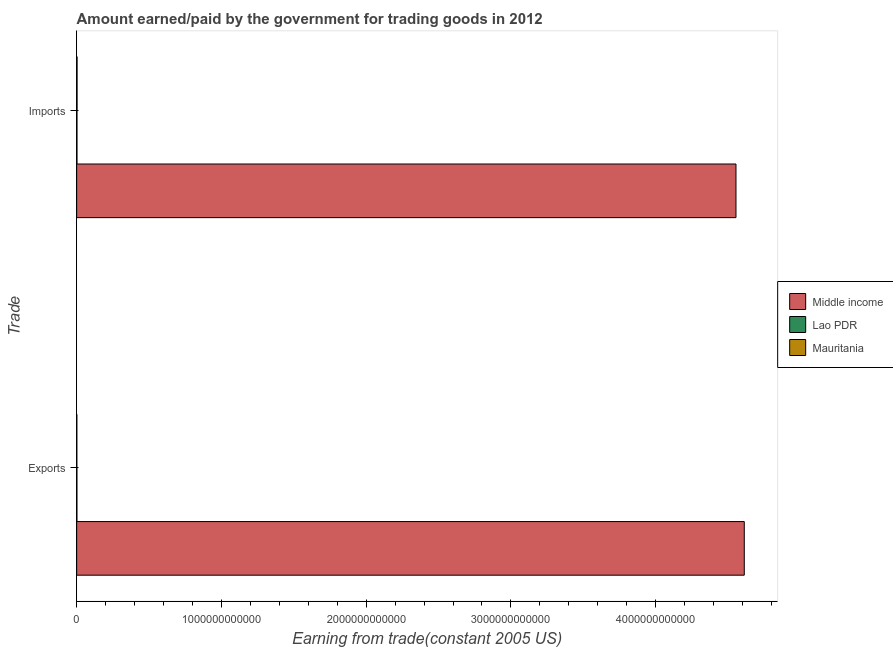How many groups of bars are there?
Provide a short and direct response. 2. Are the number of bars per tick equal to the number of legend labels?
Give a very brief answer. Yes. Are the number of bars on each tick of the Y-axis equal?
Your answer should be very brief. Yes. How many bars are there on the 1st tick from the bottom?
Make the answer very short. 3. What is the label of the 1st group of bars from the top?
Your answer should be very brief. Imports. What is the amount earned from exports in Middle income?
Provide a short and direct response. 4.61e+12. Across all countries, what is the maximum amount earned from exports?
Provide a short and direct response. 4.61e+12. Across all countries, what is the minimum amount paid for imports?
Offer a terse response. 2.28e+09. In which country was the amount paid for imports maximum?
Ensure brevity in your answer.  Middle income. In which country was the amount earned from exports minimum?
Make the answer very short. Mauritania. What is the total amount paid for imports in the graph?
Offer a very short reply. 4.56e+12. What is the difference between the amount earned from exports in Mauritania and that in Lao PDR?
Your answer should be compact. -5.59e+08. What is the difference between the amount paid for imports in Lao PDR and the amount earned from exports in Mauritania?
Your answer should be very brief. 1.02e+09. What is the average amount earned from exports per country?
Offer a terse response. 1.54e+12. What is the difference between the amount paid for imports and amount earned from exports in Lao PDR?
Make the answer very short. 4.61e+08. In how many countries, is the amount earned from exports greater than 2800000000000 US$?
Your answer should be very brief. 1. What is the ratio of the amount paid for imports in Mauritania to that in Middle income?
Provide a succinct answer. 0. In how many countries, is the amount paid for imports greater than the average amount paid for imports taken over all countries?
Your answer should be very brief. 1. What does the 1st bar from the bottom in Exports represents?
Your answer should be compact. Middle income. How many bars are there?
Your answer should be very brief. 6. Are all the bars in the graph horizontal?
Your answer should be very brief. Yes. How many countries are there in the graph?
Make the answer very short. 3. What is the difference between two consecutive major ticks on the X-axis?
Your answer should be very brief. 1.00e+12. Are the values on the major ticks of X-axis written in scientific E-notation?
Offer a very short reply. No. Where does the legend appear in the graph?
Give a very brief answer. Center right. How many legend labels are there?
Offer a terse response. 3. How are the legend labels stacked?
Offer a terse response. Vertical. What is the title of the graph?
Ensure brevity in your answer.  Amount earned/paid by the government for trading goods in 2012. What is the label or title of the X-axis?
Make the answer very short. Earning from trade(constant 2005 US). What is the label or title of the Y-axis?
Your answer should be compact. Trade. What is the Earning from trade(constant 2005 US) of Middle income in Exports?
Make the answer very short. 4.61e+12. What is the Earning from trade(constant 2005 US) of Lao PDR in Exports?
Keep it short and to the point. 1.82e+09. What is the Earning from trade(constant 2005 US) of Mauritania in Exports?
Make the answer very short. 1.26e+09. What is the Earning from trade(constant 2005 US) in Middle income in Imports?
Ensure brevity in your answer.  4.55e+12. What is the Earning from trade(constant 2005 US) of Lao PDR in Imports?
Your response must be concise. 2.28e+09. What is the Earning from trade(constant 2005 US) in Mauritania in Imports?
Make the answer very short. 2.84e+09. Across all Trade, what is the maximum Earning from trade(constant 2005 US) of Middle income?
Provide a succinct answer. 4.61e+12. Across all Trade, what is the maximum Earning from trade(constant 2005 US) in Lao PDR?
Your response must be concise. 2.28e+09. Across all Trade, what is the maximum Earning from trade(constant 2005 US) of Mauritania?
Offer a terse response. 2.84e+09. Across all Trade, what is the minimum Earning from trade(constant 2005 US) of Middle income?
Provide a short and direct response. 4.55e+12. Across all Trade, what is the minimum Earning from trade(constant 2005 US) of Lao PDR?
Ensure brevity in your answer.  1.82e+09. Across all Trade, what is the minimum Earning from trade(constant 2005 US) in Mauritania?
Your answer should be very brief. 1.26e+09. What is the total Earning from trade(constant 2005 US) in Middle income in the graph?
Your answer should be compact. 9.17e+12. What is the total Earning from trade(constant 2005 US) in Lao PDR in the graph?
Your answer should be very brief. 4.11e+09. What is the total Earning from trade(constant 2005 US) of Mauritania in the graph?
Keep it short and to the point. 4.10e+09. What is the difference between the Earning from trade(constant 2005 US) of Middle income in Exports and that in Imports?
Your response must be concise. 5.74e+1. What is the difference between the Earning from trade(constant 2005 US) of Lao PDR in Exports and that in Imports?
Offer a terse response. -4.61e+08. What is the difference between the Earning from trade(constant 2005 US) in Mauritania in Exports and that in Imports?
Offer a very short reply. -1.58e+09. What is the difference between the Earning from trade(constant 2005 US) in Middle income in Exports and the Earning from trade(constant 2005 US) in Lao PDR in Imports?
Your answer should be very brief. 4.61e+12. What is the difference between the Earning from trade(constant 2005 US) in Middle income in Exports and the Earning from trade(constant 2005 US) in Mauritania in Imports?
Your response must be concise. 4.61e+12. What is the difference between the Earning from trade(constant 2005 US) of Lao PDR in Exports and the Earning from trade(constant 2005 US) of Mauritania in Imports?
Your answer should be very brief. -1.02e+09. What is the average Earning from trade(constant 2005 US) of Middle income per Trade?
Give a very brief answer. 4.58e+12. What is the average Earning from trade(constant 2005 US) of Lao PDR per Trade?
Ensure brevity in your answer.  2.05e+09. What is the average Earning from trade(constant 2005 US) of Mauritania per Trade?
Offer a terse response. 2.05e+09. What is the difference between the Earning from trade(constant 2005 US) of Middle income and Earning from trade(constant 2005 US) of Lao PDR in Exports?
Keep it short and to the point. 4.61e+12. What is the difference between the Earning from trade(constant 2005 US) in Middle income and Earning from trade(constant 2005 US) in Mauritania in Exports?
Give a very brief answer. 4.61e+12. What is the difference between the Earning from trade(constant 2005 US) of Lao PDR and Earning from trade(constant 2005 US) of Mauritania in Exports?
Your answer should be compact. 5.59e+08. What is the difference between the Earning from trade(constant 2005 US) in Middle income and Earning from trade(constant 2005 US) in Lao PDR in Imports?
Provide a short and direct response. 4.55e+12. What is the difference between the Earning from trade(constant 2005 US) of Middle income and Earning from trade(constant 2005 US) of Mauritania in Imports?
Provide a short and direct response. 4.55e+12. What is the difference between the Earning from trade(constant 2005 US) of Lao PDR and Earning from trade(constant 2005 US) of Mauritania in Imports?
Give a very brief answer. -5.55e+08. What is the ratio of the Earning from trade(constant 2005 US) in Middle income in Exports to that in Imports?
Offer a very short reply. 1.01. What is the ratio of the Earning from trade(constant 2005 US) in Lao PDR in Exports to that in Imports?
Keep it short and to the point. 0.8. What is the ratio of the Earning from trade(constant 2005 US) of Mauritania in Exports to that in Imports?
Keep it short and to the point. 0.45. What is the difference between the highest and the second highest Earning from trade(constant 2005 US) of Middle income?
Keep it short and to the point. 5.74e+1. What is the difference between the highest and the second highest Earning from trade(constant 2005 US) of Lao PDR?
Offer a terse response. 4.61e+08. What is the difference between the highest and the second highest Earning from trade(constant 2005 US) in Mauritania?
Provide a succinct answer. 1.58e+09. What is the difference between the highest and the lowest Earning from trade(constant 2005 US) in Middle income?
Your response must be concise. 5.74e+1. What is the difference between the highest and the lowest Earning from trade(constant 2005 US) in Lao PDR?
Provide a short and direct response. 4.61e+08. What is the difference between the highest and the lowest Earning from trade(constant 2005 US) in Mauritania?
Give a very brief answer. 1.58e+09. 